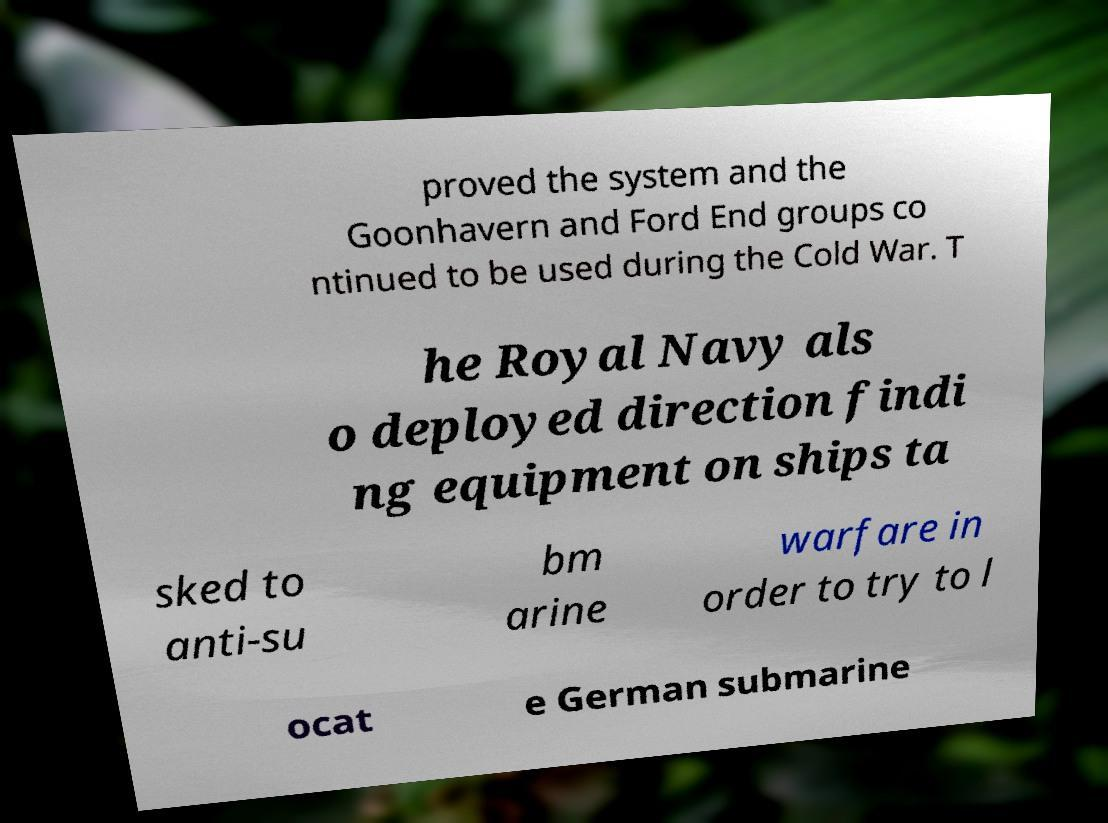Could you assist in decoding the text presented in this image and type it out clearly? proved the system and the Goonhavern and Ford End groups co ntinued to be used during the Cold War. T he Royal Navy als o deployed direction findi ng equipment on ships ta sked to anti-su bm arine warfare in order to try to l ocat e German submarine 